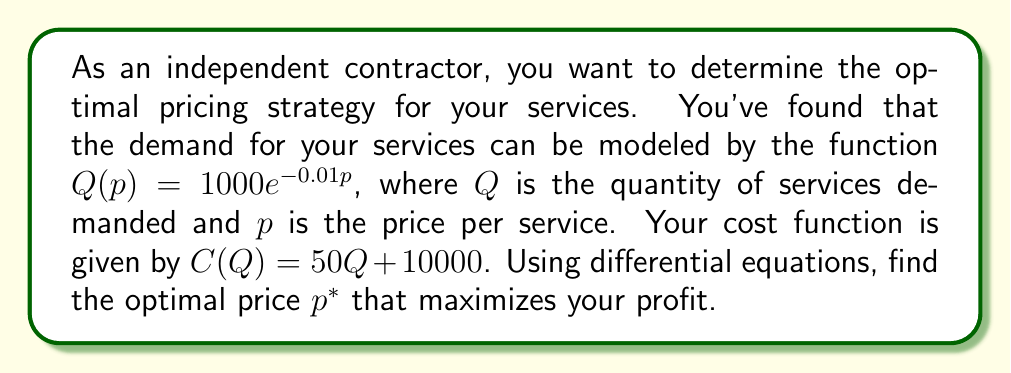Show me your answer to this math problem. To solve this problem, we'll follow these steps:

1) First, let's define the profit function $\Pi(p)$:
   $\Pi(p) = pQ(p) - C(Q(p))$

2) Substitute the given functions:
   $\Pi(p) = p(1000e^{-0.01p}) - [50(1000e^{-0.01p}) + 10000]$

3) Simplify:
   $\Pi(p) = 1000pe^{-0.01p} - 50000e^{-0.01p} - 10000$

4) To find the maximum profit, we need to find where the derivative of $\Pi(p)$ equals zero:
   $\frac{d\Pi}{dp} = 0$

5) Calculate the derivative:
   $$\begin{align}
   \frac{d\Pi}{dp} &= 1000e^{-0.01p} + 1000p(-0.01)e^{-0.01p} - 50000(-0.01)e^{-0.01p} \\
   &= 1000e^{-0.01p}(1 - 0.01p + 0.5)
   \end{align}$$

6) Set the derivative equal to zero and solve for $p$:
   $$\begin{align}
   1000e^{-0.01p}(1.5 - 0.01p) &= 0 \\
   1.5 - 0.01p &= 0 \\
   p &= 150
   \end{align}$$

7) To confirm this is a maximum, we can check the second derivative:
   $$\frac{d^2\Pi}{dp^2} = -10e^{-0.01p}(2.5 - 0.01p)$$
   At $p = 150$, this is negative, confirming a maximum.

Therefore, the optimal price $p^*$ is 150.
Answer: The optimal price $p^*$ that maximizes profit is $150 per service. 